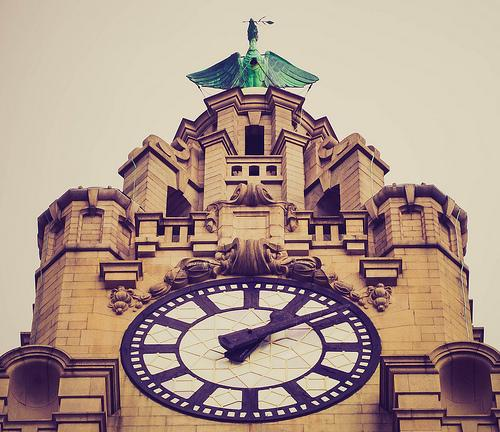What kind of building can be seen in the image? A clock tower made of stone with various balcony and window features. What is unique about the green statue in the image? The green statue is a bird holding a rosebud in its mouth. Briefly describe the sentiment of the image. The image portrays a sense of history and architectural grandeur due to the old stone clock tower and decorative features. Describe one of the objects on the side of the tower. There is a steel pipe on the side of the tower. Provide a brief analysis of object interactions in the image. The clocks on the building are the main focal points, with the green bird statue interacting as a decorative element, and the windows and pipes highlight the tower's structure and details. Count the number of windows mentioned in the image descriptions. There are nine windows mentioned in the image descriptions. List three objects depicted in the image. Clock on a building, green statue, and pipe on the side of the tower. What color is the statue, and what is its position in the image? The statue is green and positioned on the top of the tower. Describe the appearance of the clock in the image. The clock is large with a white face, gold design, black number marks and hands, and stripes representing the numbers. Mention a key attribute of the windows in the tower. The windows in the tower are arched, with some open and some closed. Please describe the color and appearance of the clock in the image. The clock is white and black with stripes to represent numbers, and the number marks and hands are black. Is there a cat sitting near the clock on the wall? I think I saw it in the image. No, it's not mentioned in the image. Does the clock represent numbers with traditional Arabic numerals or a different method? The clock represents numbers with stripes instead of traditional Arabic numerals. Express how the building in the image looks in terms of age and material. The building looks old and is made of stone. Classify the parts of the image with different labels such as clock, statue, window, railing, etc. Clock: X:152 Y:269 Width:242 Height:242, Statue: X:198 Y:20 Width:102 Height:102, Window: X:74 Y:199 Width:33 Height:33, Railing: X:133 Y:206 Width:236 Height:236. Provide an overview of the image's subject matter and notable features. The image shows a clock tower with a verdigris bird on top, the clock is white and black, the building is made of stone, and there are open and closed arched windows on the tower. What are the predominant colors of the clock face? The clock face is predominantly white with a gold design and black number marks and hands. Assess the quality of the image in terms of exposure and color balance. The image has appropriate exposure and balanced colors. Determine which caption describes the location of the green statue: "a green statue at the base", "a green winged statue on top", or "a green statue in the middle". A green winged statue on top. Identify the location and dimensions of the clock on the wall in the image. X:152 Y:269 Width:242 Height:242 Choose the correct statement about the windows in the image: "All windows are open", "All windows are closed", or "Some windows are open and some are closed". Some windows are open and some are closed. Describe the attributes of the pipe on the side of the tower. The pipe is steel and has dimensions X:451 Y:200 Width:26 Height:26. Extract any text or numerical values visible in the image. The clock reads 209. Analyze the quality of the photograph in terms of clarity and focus. The image quality is good with clear details and objects in focus. Identify any unusual or unexpected elements in the image. There are no unusual or unexpected elements detected in the image. Identify any details about the green winged statue that stands out. The statue is a green bird with a rosebud in its mouth, and it's on the top of the tower. Describe the shape and placement of windows in the image. There are both open and closed arched windows located on the sides of the tower. Describe any interactions between the green bird statue and any objects it might be holding. The green bird statue is holding a rose bud in its mouth. Name three different objects with their coordinates found in the image. Clock: X:152 Y:269 Width:242 Height:242, Statue: X:198 Y:20 Width:102 Height:102, Window: X:74 Y:199 Width:33 Height:33. What color is the building made of? The building is made of stone, so it is grey. 